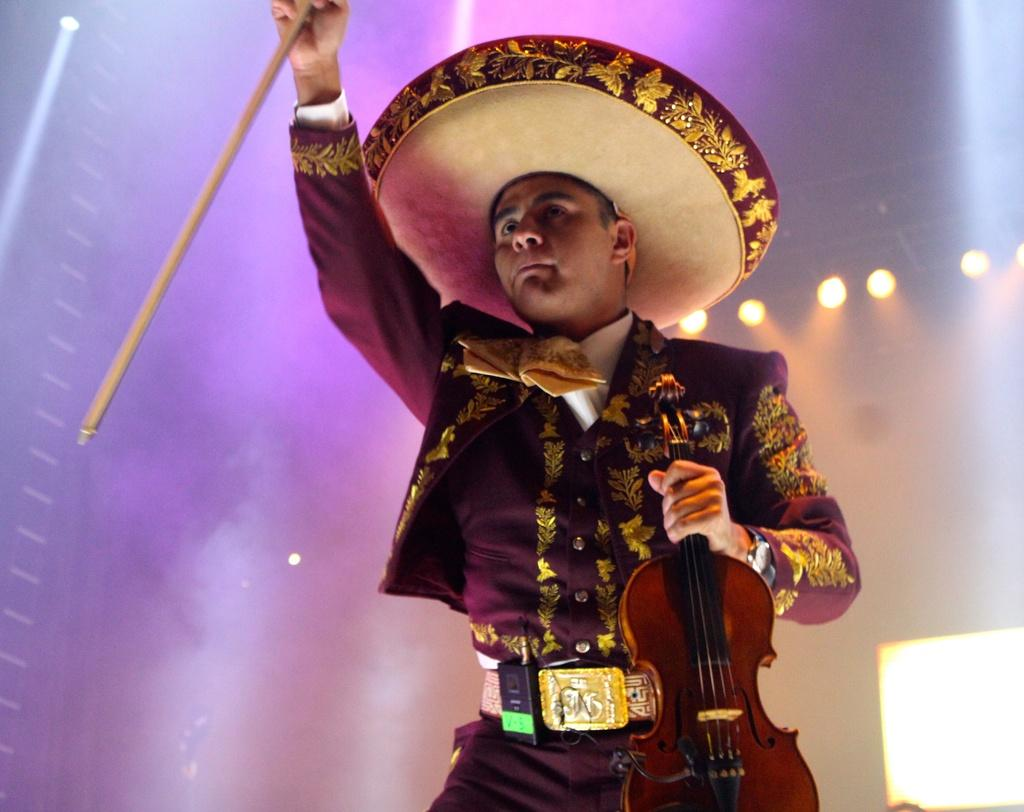Who is the main subject in the image? There is a man in the image. Where is the man positioned in the image? The man is standing in the middle of the image. What is the man holding in the image? The man is holding a violin. What can be seen in the background of the image? There are lights visible in the background of the image. Can you describe the tiger's expression in the image? There is no tiger present in the image; it features a man holding a violin. 